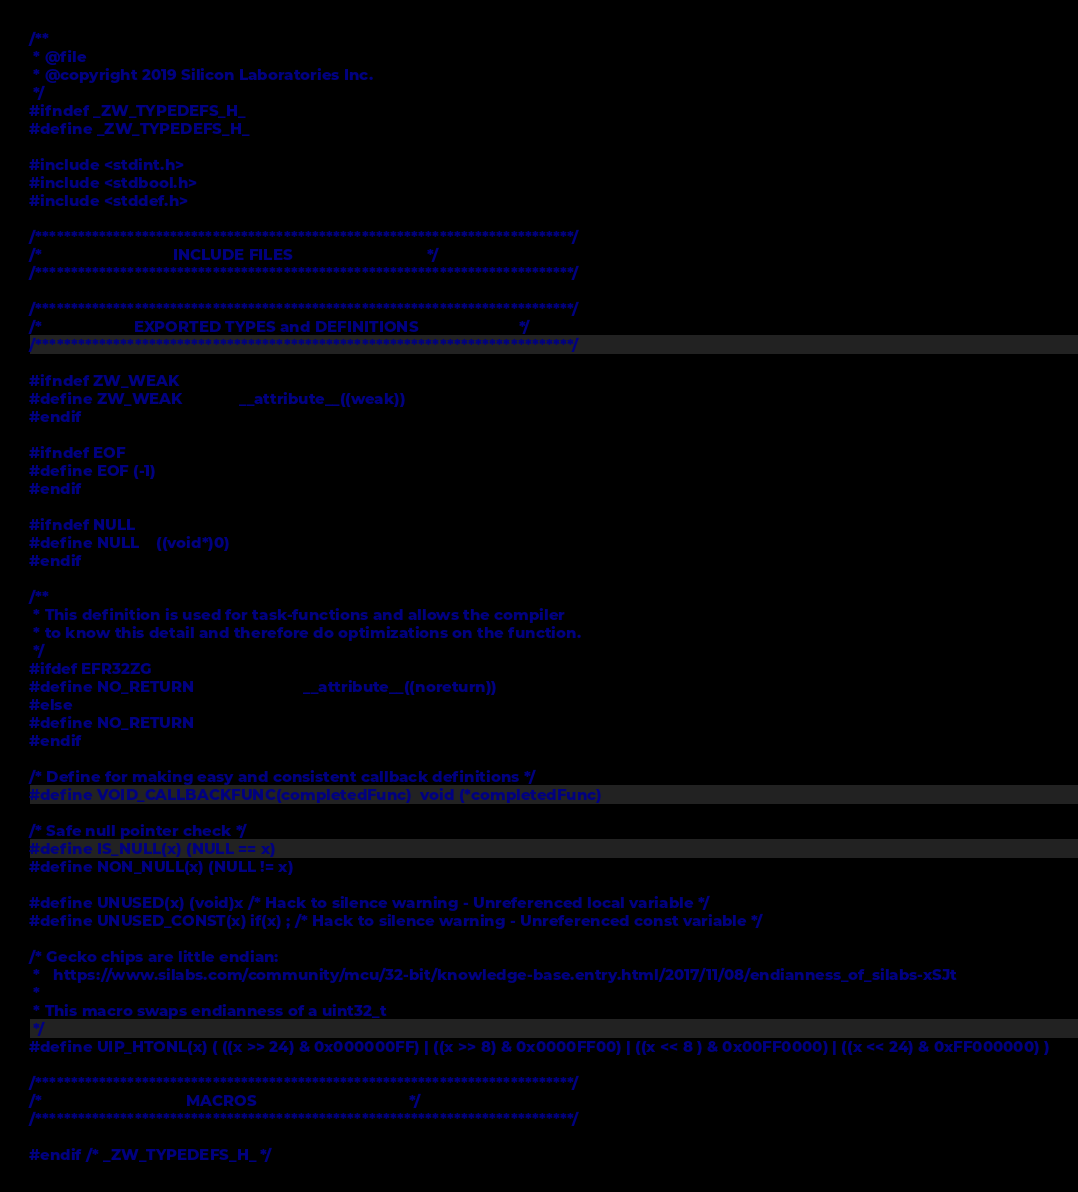Convert code to text. <code><loc_0><loc_0><loc_500><loc_500><_C_>/**
 * @file
 * @copyright 2019 Silicon Laboratories Inc.
 */
#ifndef _ZW_TYPEDEFS_H_
#define _ZW_TYPEDEFS_H_

#include <stdint.h>
#include <stdbool.h>
#include <stddef.h>

/****************************************************************************/
/*                              INCLUDE FILES                               */
/****************************************************************************/

/****************************************************************************/
/*                     EXPORTED TYPES and DEFINITIONS                       */
/****************************************************************************/

#ifndef ZW_WEAK
#define ZW_WEAK             __attribute__((weak))
#endif

#ifndef EOF
#define EOF (-1)
#endif

#ifndef NULL
#define NULL    ((void*)0)
#endif

/**
 * This definition is used for task-functions and allows the compiler
 * to know this detail and therefore do optimizations on the function.
 */
#ifdef EFR32ZG
#define NO_RETURN                         __attribute__((noreturn))
#else
#define NO_RETURN
#endif

/* Define for making easy and consistent callback definitions */
#define VOID_CALLBACKFUNC(completedFunc)  void (*completedFunc)

/* Safe null pointer check */
#define IS_NULL(x) (NULL == x)
#define NON_NULL(x) (NULL != x)

#define UNUSED(x) (void)x /* Hack to silence warning - Unreferenced local variable */
#define UNUSED_CONST(x) if(x) ; /* Hack to silence warning - Unreferenced const variable */

/* Gecko chips are little endian:
 *   https://www.silabs.com/community/mcu/32-bit/knowledge-base.entry.html/2017/11/08/endianness_of_silabs-xSJt
 *
 * This macro swaps endianness of a uint32_t
 */
#define UIP_HTONL(x) ( ((x >> 24) & 0x000000FF) | ((x >> 8) & 0x0000FF00) | ((x << 8 ) & 0x00FF0000) | ((x << 24) & 0xFF000000) )

/****************************************************************************/
/*                                 MACROS                                   */
/****************************************************************************/

#endif /* _ZW_TYPEDEFS_H_ */
</code> 